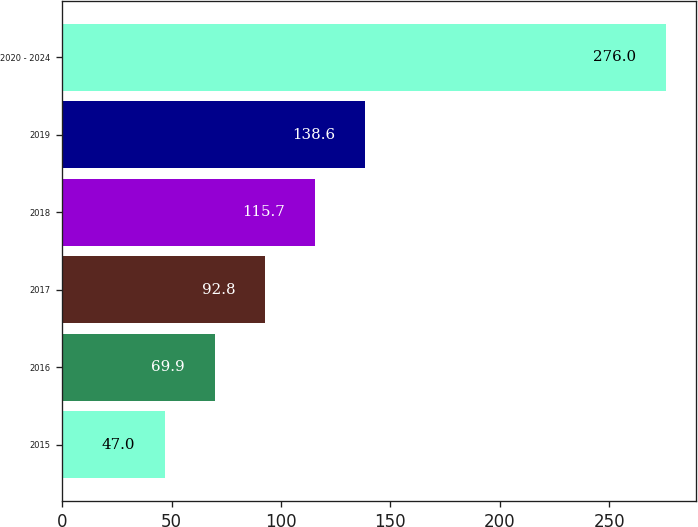<chart> <loc_0><loc_0><loc_500><loc_500><bar_chart><fcel>2015<fcel>2016<fcel>2017<fcel>2018<fcel>2019<fcel>2020 - 2024<nl><fcel>47<fcel>69.9<fcel>92.8<fcel>115.7<fcel>138.6<fcel>276<nl></chart> 